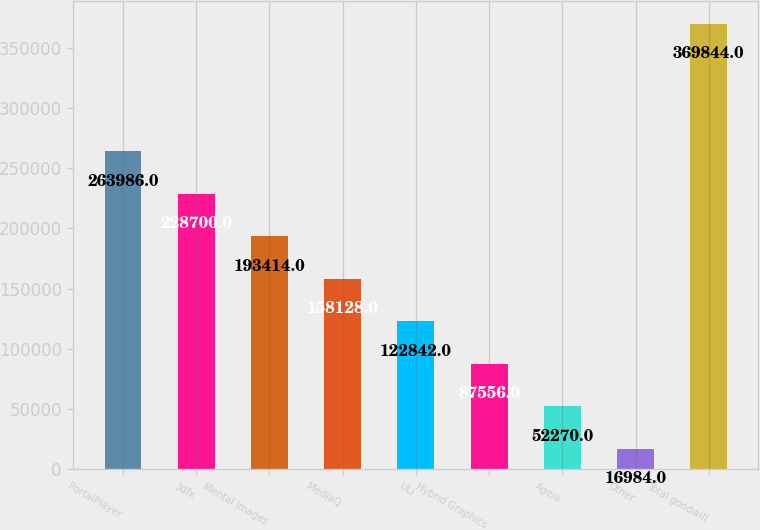Convert chart. <chart><loc_0><loc_0><loc_500><loc_500><bar_chart><fcel>PortalPlayer<fcel>3dfx<fcel>Mental Images<fcel>MediaQ<fcel>ULi<fcel>Hybrid Graphics<fcel>Ageia<fcel>Other<fcel>Total goodwill<nl><fcel>263986<fcel>228700<fcel>193414<fcel>158128<fcel>122842<fcel>87556<fcel>52270<fcel>16984<fcel>369844<nl></chart> 